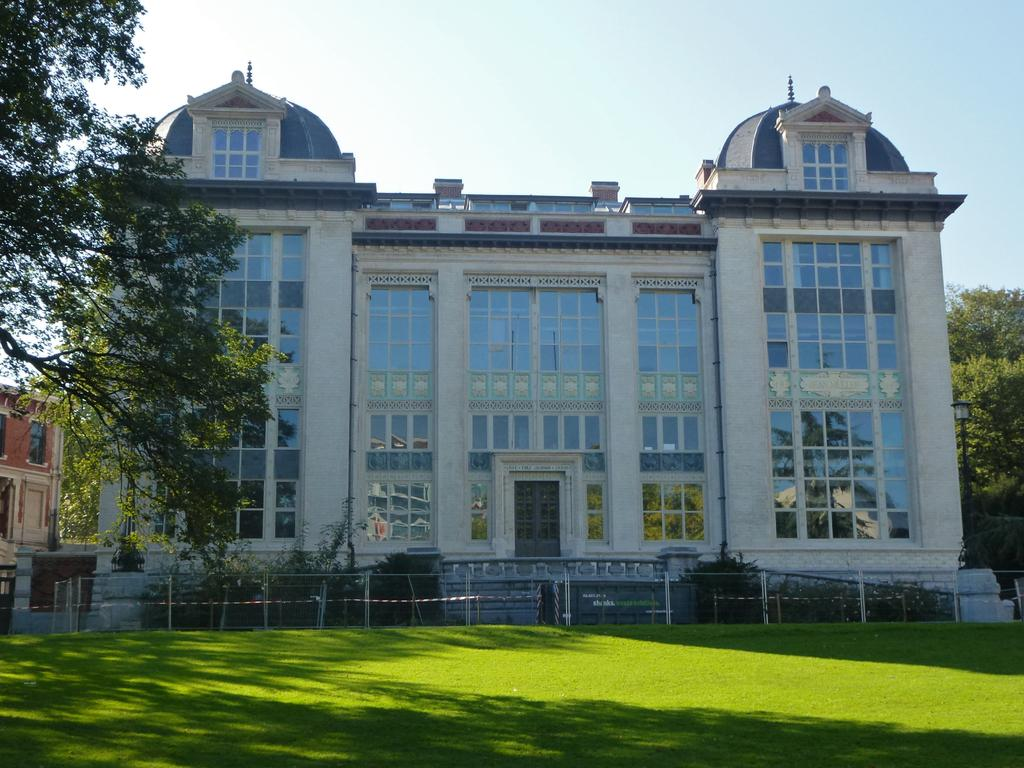What type of structures can be seen in the image? There are buildings in the image. What other natural elements are present in the image? There are trees in the image. How would you describe the sky in the image? The sky is blue and cloudy. What type of ground surface is visible in the image? There is grass on the ground in the image. What direction is the ship sailing in the image? There is no ship present in the image. What type of root system can be seen supporting the trees in the image? There is no root system visible in the image, as only the trees' trunks and branches are shown. 